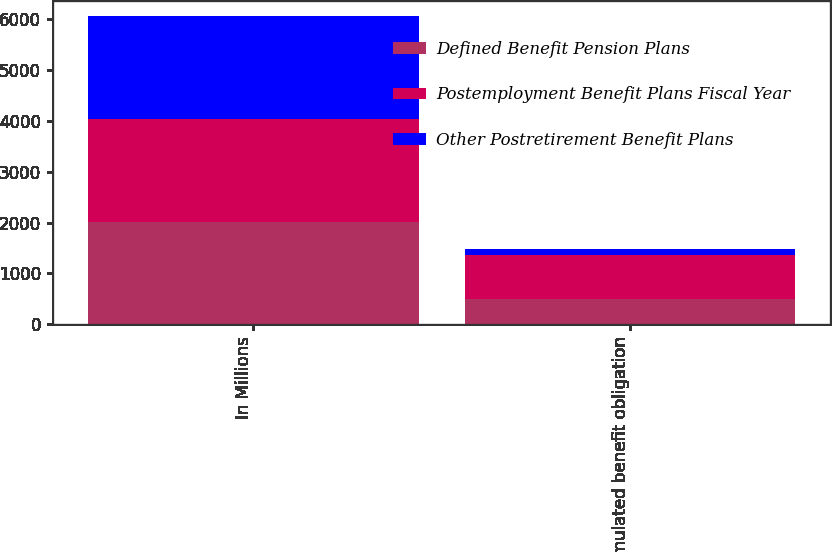Convert chart to OTSL. <chart><loc_0><loc_0><loc_500><loc_500><stacked_bar_chart><ecel><fcel>In Millions<fcel>Accumulated benefit obligation<nl><fcel>Defined Benefit Pension Plans<fcel>2018<fcel>498.8<nl><fcel>Postemployment Benefit Plans Fiscal Year<fcel>2018<fcel>868.3<nl><fcel>Other Postretirement Benefit Plans<fcel>2018<fcel>122<nl></chart> 